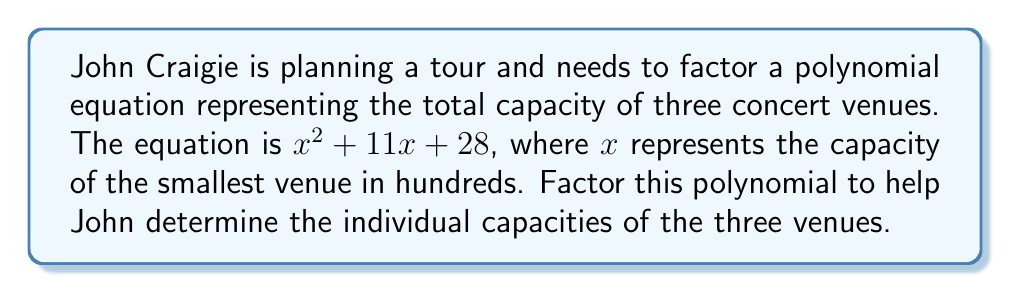Solve this math problem. To factor the polynomial $x^2 + 11x + 28$, we'll use the following steps:

1) First, identify that this is a quadratic equation in the form $ax^2 + bx + c$, where $a=1$, $b=11$, and $c=28$.

2) We need to find two numbers that multiply to give $ac = 1 \times 28 = 28$ and add up to $b = 11$.

3) The factors of 28 are: 1, 2, 4, 7, 14, 28. By inspection, we can see that 4 and 7 add up to 11.

4) Rewrite the middle term using these numbers:
   $$x^2 + 11x + 28 = x^2 + 4x + 7x + 28$$

5) Group the terms:
   $$(x^2 + 4x) + (7x + 28)$$

6) Factor out the common factor from each group:
   $$x(x + 4) + 7(x + 4)$$

7) Factor out the common binomial $(x + 4)$:
   $$(x + 7)(x + 4)$$

Therefore, the factored form of the polynomial is $(x + 7)(x + 4)$.

This means the capacity of the smallest venue is $x$ hundred, the medium venue is $(x + 4)$ hundred, and the largest venue is $(x + 7)$ hundred.
Answer: $(x + 7)(x + 4)$ 